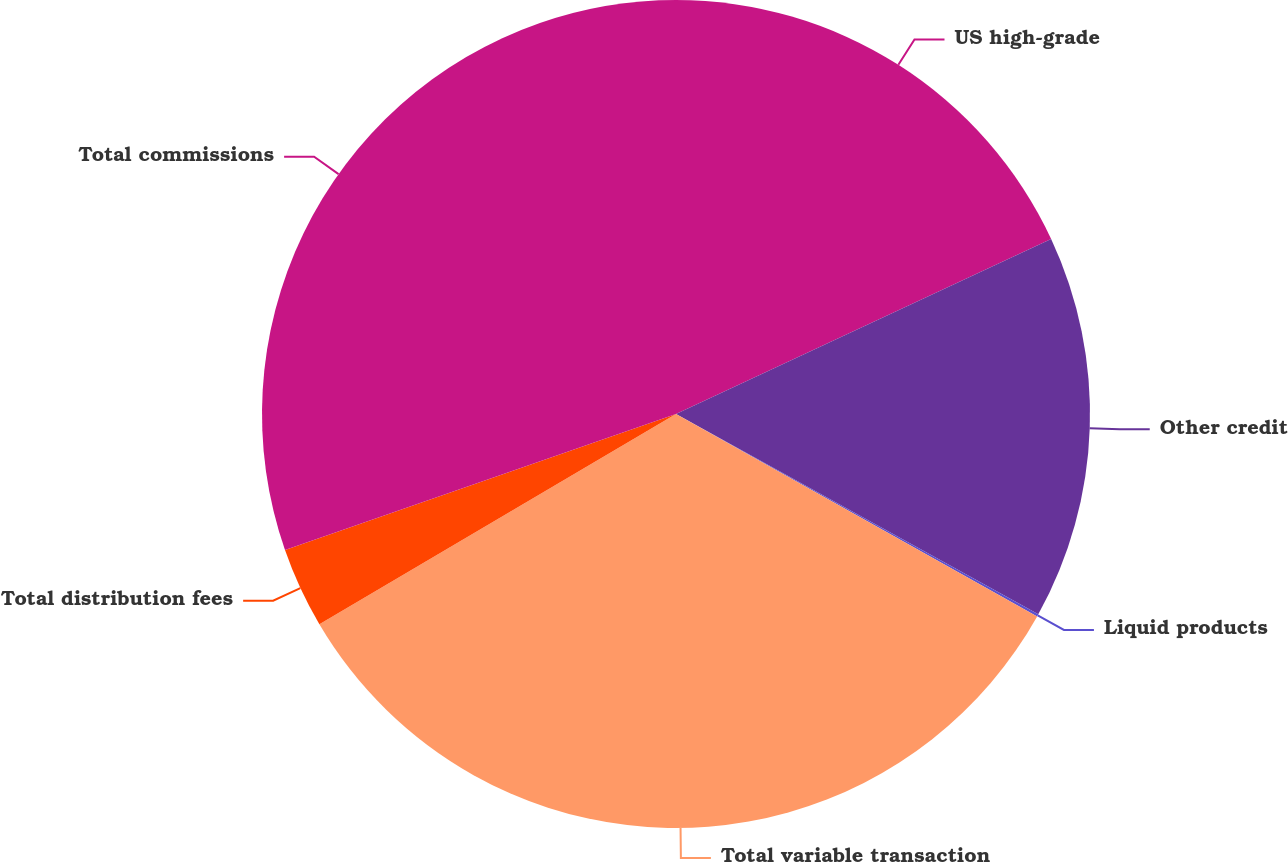Convert chart. <chart><loc_0><loc_0><loc_500><loc_500><pie_chart><fcel>US high-grade<fcel>Other credit<fcel>Liquid products<fcel>Total variable transaction<fcel>Total distribution fees<fcel>Total commissions<nl><fcel>18.05%<fcel>14.99%<fcel>0.09%<fcel>33.39%<fcel>3.15%<fcel>30.33%<nl></chart> 